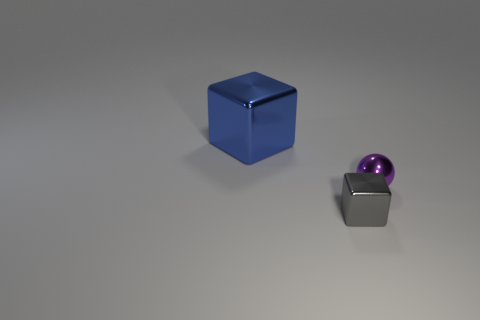Add 2 tiny spheres. How many objects exist? 5 Subtract all blocks. How many objects are left? 1 Add 1 big purple cylinders. How many big purple cylinders exist? 1 Subtract 0 red cubes. How many objects are left? 3 Subtract all blue things. Subtract all tiny gray metallic things. How many objects are left? 1 Add 2 large blue cubes. How many large blue cubes are left? 3 